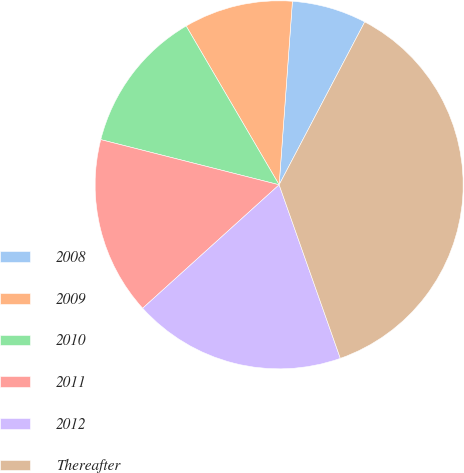<chart> <loc_0><loc_0><loc_500><loc_500><pie_chart><fcel>2008<fcel>2009<fcel>2010<fcel>2011<fcel>2012<fcel>Thereafter<nl><fcel>6.55%<fcel>9.58%<fcel>12.62%<fcel>15.65%<fcel>18.69%<fcel>36.9%<nl></chart> 